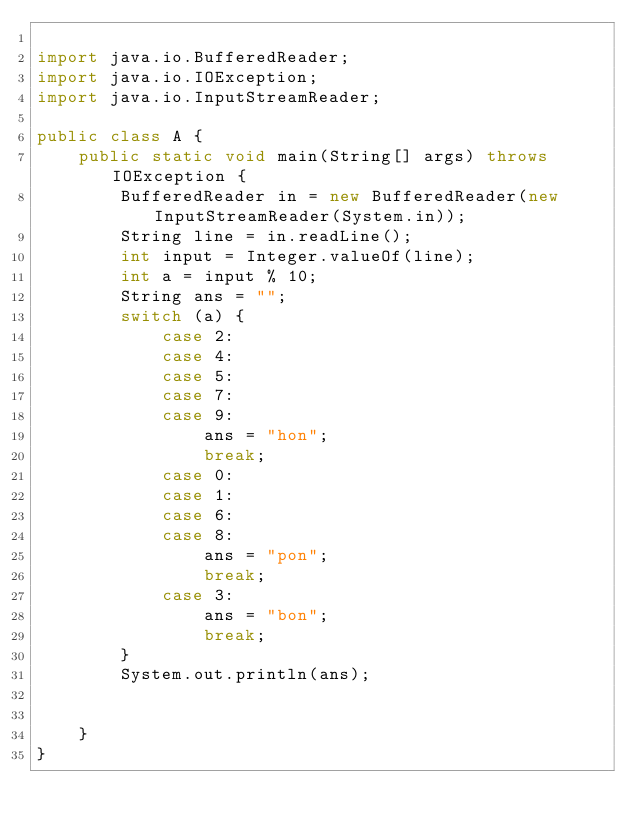<code> <loc_0><loc_0><loc_500><loc_500><_Java_>
import java.io.BufferedReader;
import java.io.IOException;
import java.io.InputStreamReader;

public class A {
    public static void main(String[] args) throws IOException {
        BufferedReader in = new BufferedReader(new InputStreamReader(System.in));
        String line = in.readLine();
        int input = Integer.valueOf(line);
        int a = input % 10;
        String ans = "";
        switch (a) {
            case 2:
            case 4:
            case 5:
            case 7:
            case 9:
                ans = "hon";
                break;
            case 0:
            case 1:
            case 6:
            case 8:
                ans = "pon";
                break;
            case 3:
                ans = "bon";
                break;
        }
        System.out.println(ans);


    }
}</code> 